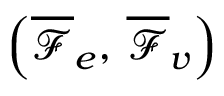<formula> <loc_0><loc_0><loc_500><loc_500>\left ( \overline { \mathcal { F } } _ { e } , \, \overline { \mathcal { F } } _ { v } \right )</formula> 